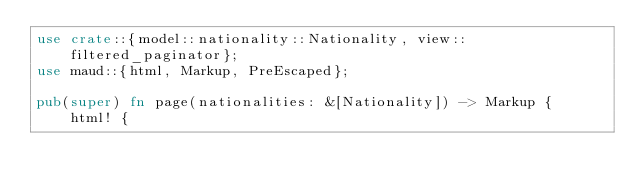<code> <loc_0><loc_0><loc_500><loc_500><_Rust_>use crate::{model::nationality::Nationality, view::filtered_paginator};
use maud::{html, Markup, PreEscaped};

pub(super) fn page(nationalities: &[Nationality]) -> Markup {
    html! {</code> 